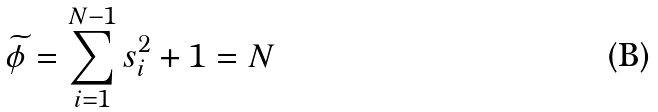<formula> <loc_0><loc_0><loc_500><loc_500>\widetilde { \phi } = \sum _ { i = 1 } ^ { N - 1 } s _ { i } ^ { 2 } + 1 = N</formula> 